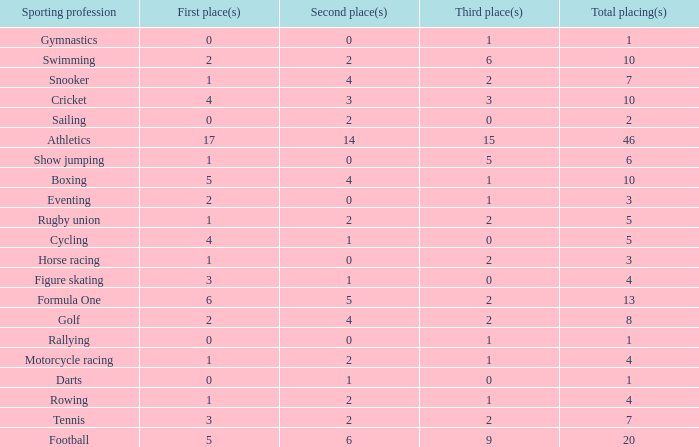How many second place showings does snooker have? 4.0. 